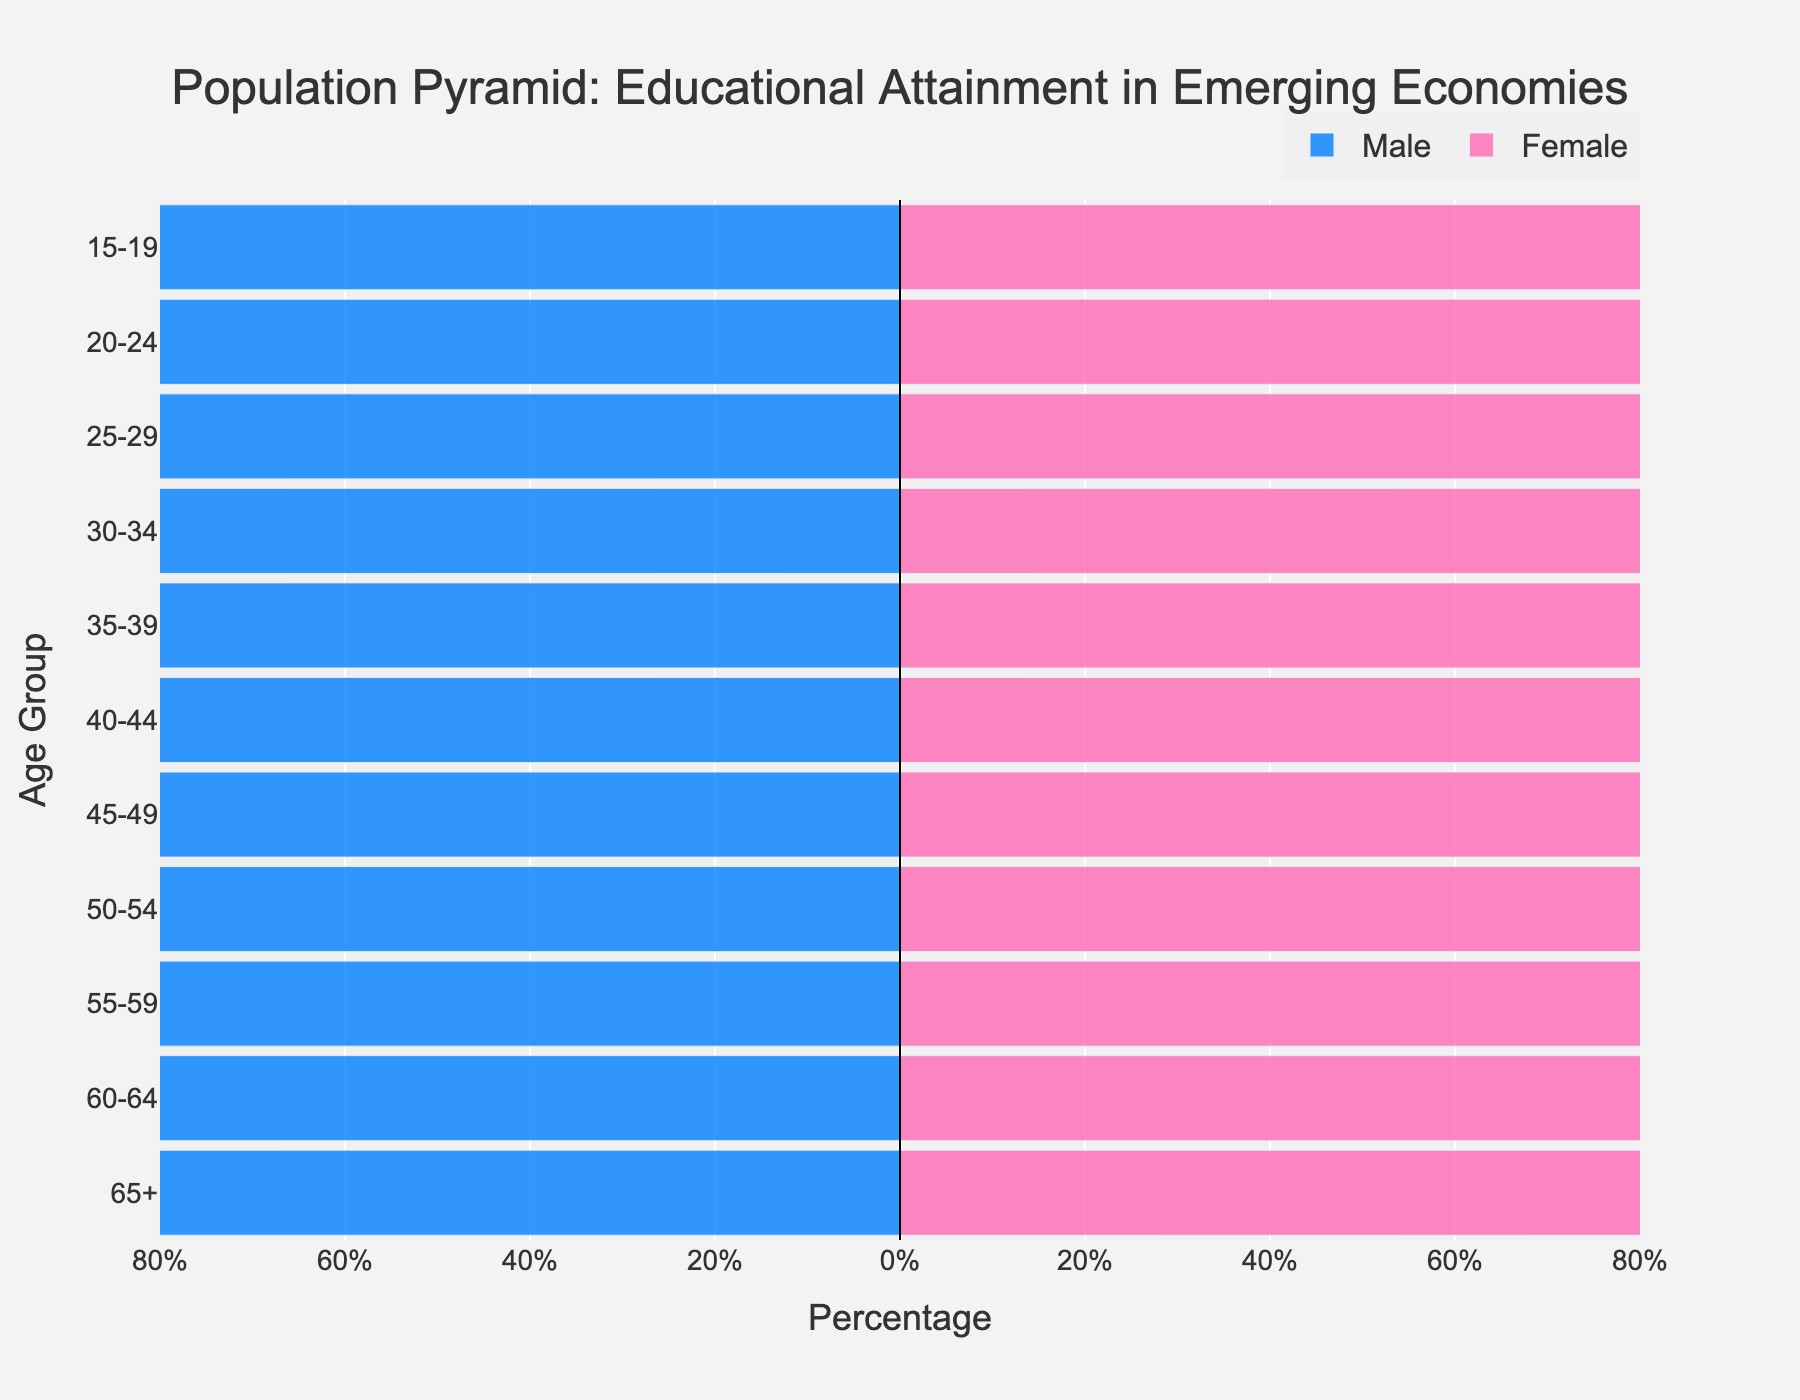What is the title of the figure? The title is located at the top of the figure. It provides a brief description of the content and purpose.
Answer: Population Pyramid: Educational Attainment in Emerging Economies Which age group has the highest percentage of males with primary or less education? Locate the male bars and find the segment labeled 'Primary or Less' with the highest value.
Answer: 65+ What is the most common educational attainment level for females aged 20-24? Look at the female bars for the 20-24 age group and identify the largest segment.
Answer: Secondary How does the percentage of males with tertiary education change from age group 15-19 to age group 25-29? Compare the values in the tertiary segment for males between the two specified age groups. Note the difference or change.
Answer: Increases What is the difference in the percentage of females with secondary education between age groups 30-34 and 60-64? Find the values for females with secondary education in both age groups and calculate the difference.
Answer: 22.3% Which gender has a higher percentage of tertiary education in the age group 50-54? Compare the tertiary education percentage for both males and females in the 50-54 age group.
Answer: Neither, they are equal What is the trend in primary or less education attainment for males as they age from group 20-24 to 65+? Observe the primary or less education percentage for males across the mentioned age groups and describe the pattern.
Answer: Increases How many age groups have a higher percentage of females with primary or less education than males? Compare the primary or less education percentage for females and males across all age groups and count the groups where females have a higher percentage.
Answer: 2 What is the percentage gap between males and females with primary or less education in the age group 55-59? Subtract the percentage of males with primary or less education from the percentage of females in the 55-59 age group.
Answer: 2.2% Which age group shows the smallest gender gap in secondary education? Compare the secondary education percentage for both males and females across all age groups and identify the group with the smallest difference.
Answer: 40-44 